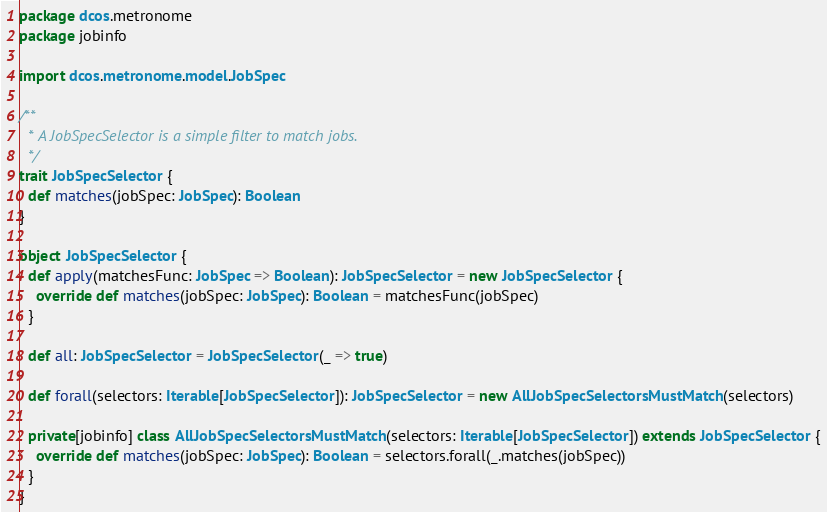Convert code to text. <code><loc_0><loc_0><loc_500><loc_500><_Scala_>package dcos.metronome
package jobinfo

import dcos.metronome.model.JobSpec

/**
  * A JobSpecSelector is a simple filter to match jobs.
  */
trait JobSpecSelector {
  def matches(jobSpec: JobSpec): Boolean
}

object JobSpecSelector {
  def apply(matchesFunc: JobSpec => Boolean): JobSpecSelector = new JobSpecSelector {
    override def matches(jobSpec: JobSpec): Boolean = matchesFunc(jobSpec)
  }

  def all: JobSpecSelector = JobSpecSelector(_ => true)

  def forall(selectors: Iterable[JobSpecSelector]): JobSpecSelector = new AllJobSpecSelectorsMustMatch(selectors)

  private[jobinfo] class AllJobSpecSelectorsMustMatch(selectors: Iterable[JobSpecSelector]) extends JobSpecSelector {
    override def matches(jobSpec: JobSpec): Boolean = selectors.forall(_.matches(jobSpec))
  }
}
</code> 